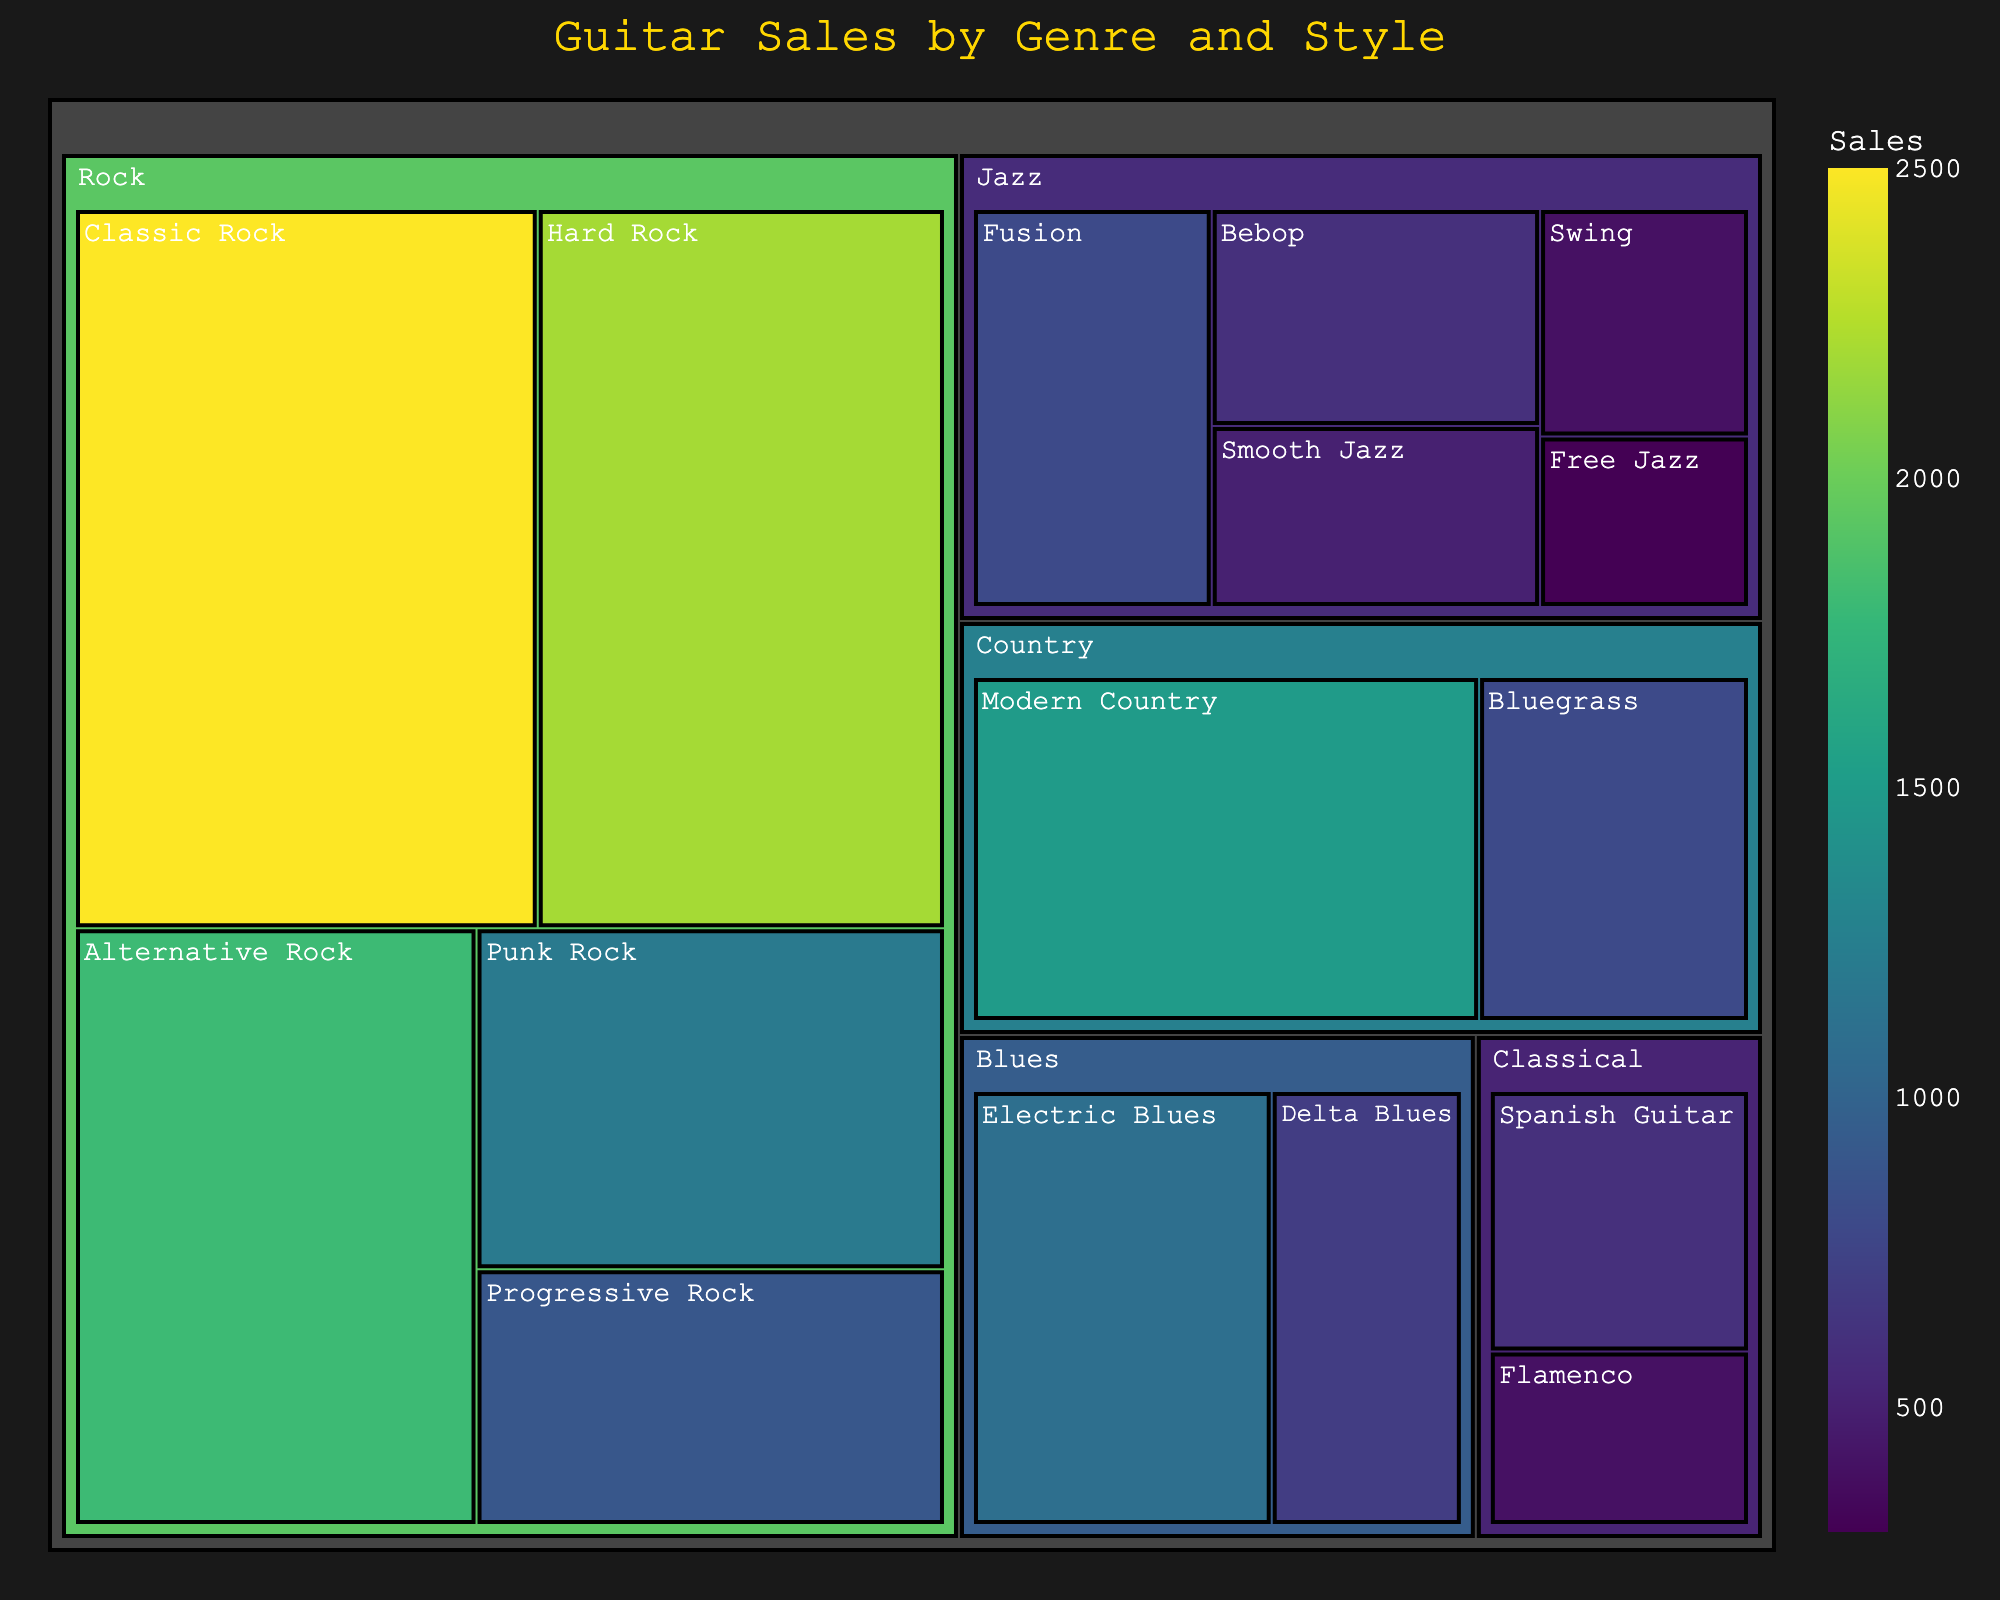What's the largest subcategory in the Rock genre in terms of sales? The figure shows different subcategories under the Rock genre. Classic Rock has the highest sales with 2500 units, more than Hard Rock (2200 units), Alternative Rock (1800 units), Punk Rock (1200 units), and Progressive Rock (900 units).
Answer: Classic Rock Which genre has the lowest total guitar sales? Summing the sales of each subcategory within each genre, Jazz has the lowest total sales (800 + 600 + 500 + 400 + 300 = 2600 units), compared to Rock, Blues, Country, and Classical.
Answer: Jazz Compare the sales of Alternative Rock and Modern Country. Which has higher sales and by how much? Alternative Rock has sales of 1800 units, and Modern Country has 1500 units. The difference is 1800 - 1500 = 300 units, with Alternative Rock having higher sales.
Answer: Alternative Rock by 300 units What is the total sales of all guitar styles under the Blues genre? Adding the sales of Electric Blues (1100 units) and Delta Blues (700 units) gives a total of 1100 + 700 = 1800 units.
Answer: 1800 units How do the total sales of Rock compare to the total sales of Jazz? Summing the sales for Rock (2500 + 2200 + 1800 + 1200 + 900 = 8600 units) and Jazz (800 + 600 + 500 + 400 + 300 = 2600 units), Rock sales are significantly higher. 8600 - 2600 = 6000 units more.
Answer: Rock by 6000 units Which subcategory has the lowest sales in the Classical genre? The Classical genre includes Spanish Guitar with 600 units and Flamenco with 400 units. Flamenco has the lowest sales.
Answer: Flamenco What is the combined sales of Smooth Jazz and Swing styles? Smooth Jazz has 500 units and Swing has 400 units. Combined sales are 500 + 400 = 900 units.
Answer: 900 units Which genre has the second-highest sales? Summing the sales of each genre, Rock has the highest (8600 units), and Country has the second-highest total (Modern Country 1500 + Bluegrass 800 = 2300 units).
Answer: Country How do the total sales of Hard Rock and Bebop compare? Hard Rock has sales of 2200 units and Bebop has 600 units. Hard Rock has significantly higher sales by 2200 - 600 = 1600 units.
Answer: Hard Rock by 1600 units 